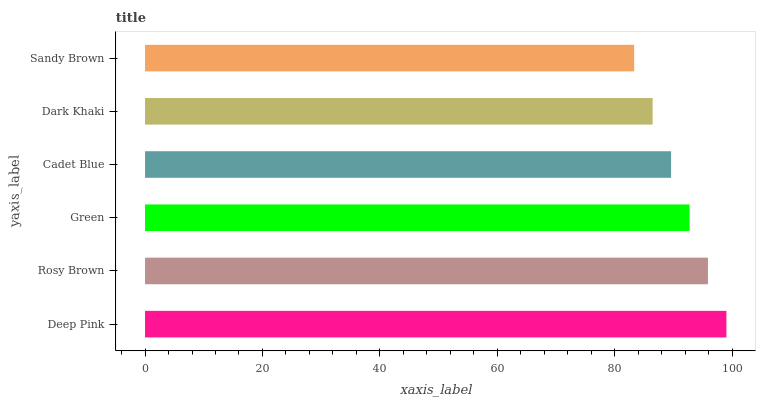Is Sandy Brown the minimum?
Answer yes or no. Yes. Is Deep Pink the maximum?
Answer yes or no. Yes. Is Rosy Brown the minimum?
Answer yes or no. No. Is Rosy Brown the maximum?
Answer yes or no. No. Is Deep Pink greater than Rosy Brown?
Answer yes or no. Yes. Is Rosy Brown less than Deep Pink?
Answer yes or no. Yes. Is Rosy Brown greater than Deep Pink?
Answer yes or no. No. Is Deep Pink less than Rosy Brown?
Answer yes or no. No. Is Green the high median?
Answer yes or no. Yes. Is Cadet Blue the low median?
Answer yes or no. Yes. Is Dark Khaki the high median?
Answer yes or no. No. Is Sandy Brown the low median?
Answer yes or no. No. 